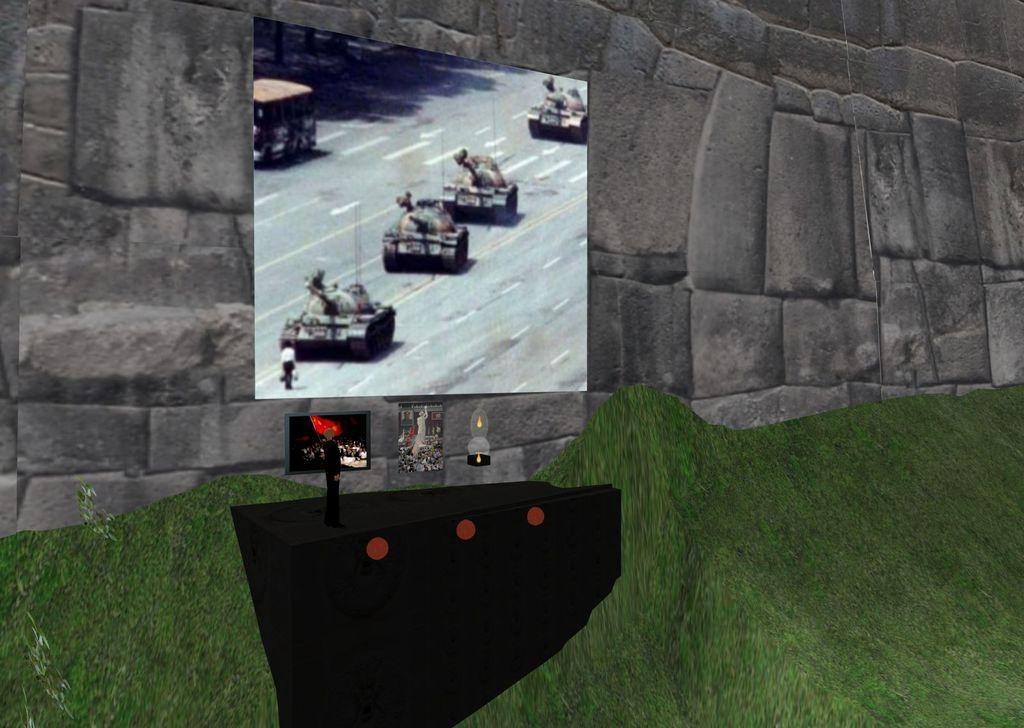What type of image is being described? The image is an animation. What is the main object in the center of the image? There is a screen in the center of the image. What is located next to the screen in the image? There is a remote in the center of the image. What type of natural environment is depicted at the bottom of the image? There is grass at the bottom of the image. What type of structure is depicted at the top of the image? There is a well at the top of the image. What type of air is present in the image? There is no mention of air in the image. --- Facts: 1. There is a person in the image. 2. The person is wearing a hat. 3. The person is holding a book. 4. The person is sitting on a chair. 5. There is a table next to the person. Absurd Topics: elephant, ocean, sunrise Conversation: Who or what is present in the image? There is a person in the image. What is the person wearing in the image? The person is wearing a hat in the image. What is the person holding in the image? The person is holding a book in the image. What is the person's position in the image? The person is sitting on a chair in the image. What object is next to the person in the image? There is a table next to the person in the image. Reasoning: Let's think step by step in order to produce the conversation. We start by identifying the main subject of the image, which is the person. Then, we describe the person's attire, specifically mentioning the hat. Next, we observe the person's actions, noting that they are holding a book. After that, we describe the person's position in the image, which is sitting on a chair. Finally, we describe the object next to the person in the image, which is a table. Each question is designed to elicit a specific detail about the image that is known from the provided facts. Absurd Question/Answer: Can you see an elephant in the image? There is no mention of an elephant in the image. --- Facts: 1. There is a dog in the image. 2. The dog is sitting on a mat. 3. The dog is wagging its tail. 4. There is a bowl of water next to the dog. 5. There is a window in the background of the image. Absurd Topics: carrot, rabbit, moon Conversation: What type of animal is present in the image? There is a dog in the image. What is the dog's position in the image? The dog is sitting 